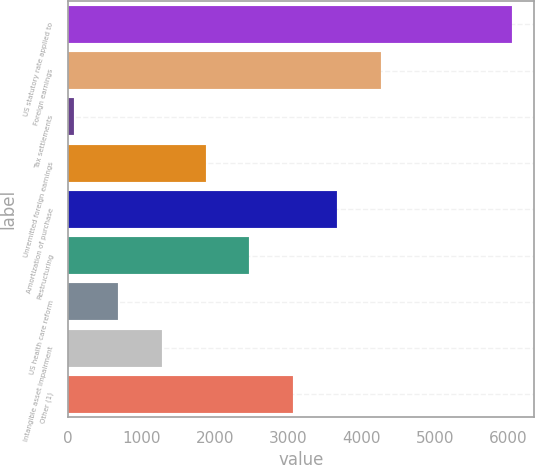Convert chart. <chart><loc_0><loc_0><loc_500><loc_500><bar_chart><fcel>US statutory rate applied to<fcel>Foreign earnings<fcel>Tax settlements<fcel>Unremitted foreign earnings<fcel>Amortization of purchase<fcel>Restructuring<fcel>US health care reform<fcel>Intangible asset impairment<fcel>Other (1)<nl><fcel>6049<fcel>4261<fcel>89<fcel>1877<fcel>3665<fcel>2473<fcel>685<fcel>1281<fcel>3069<nl></chart> 